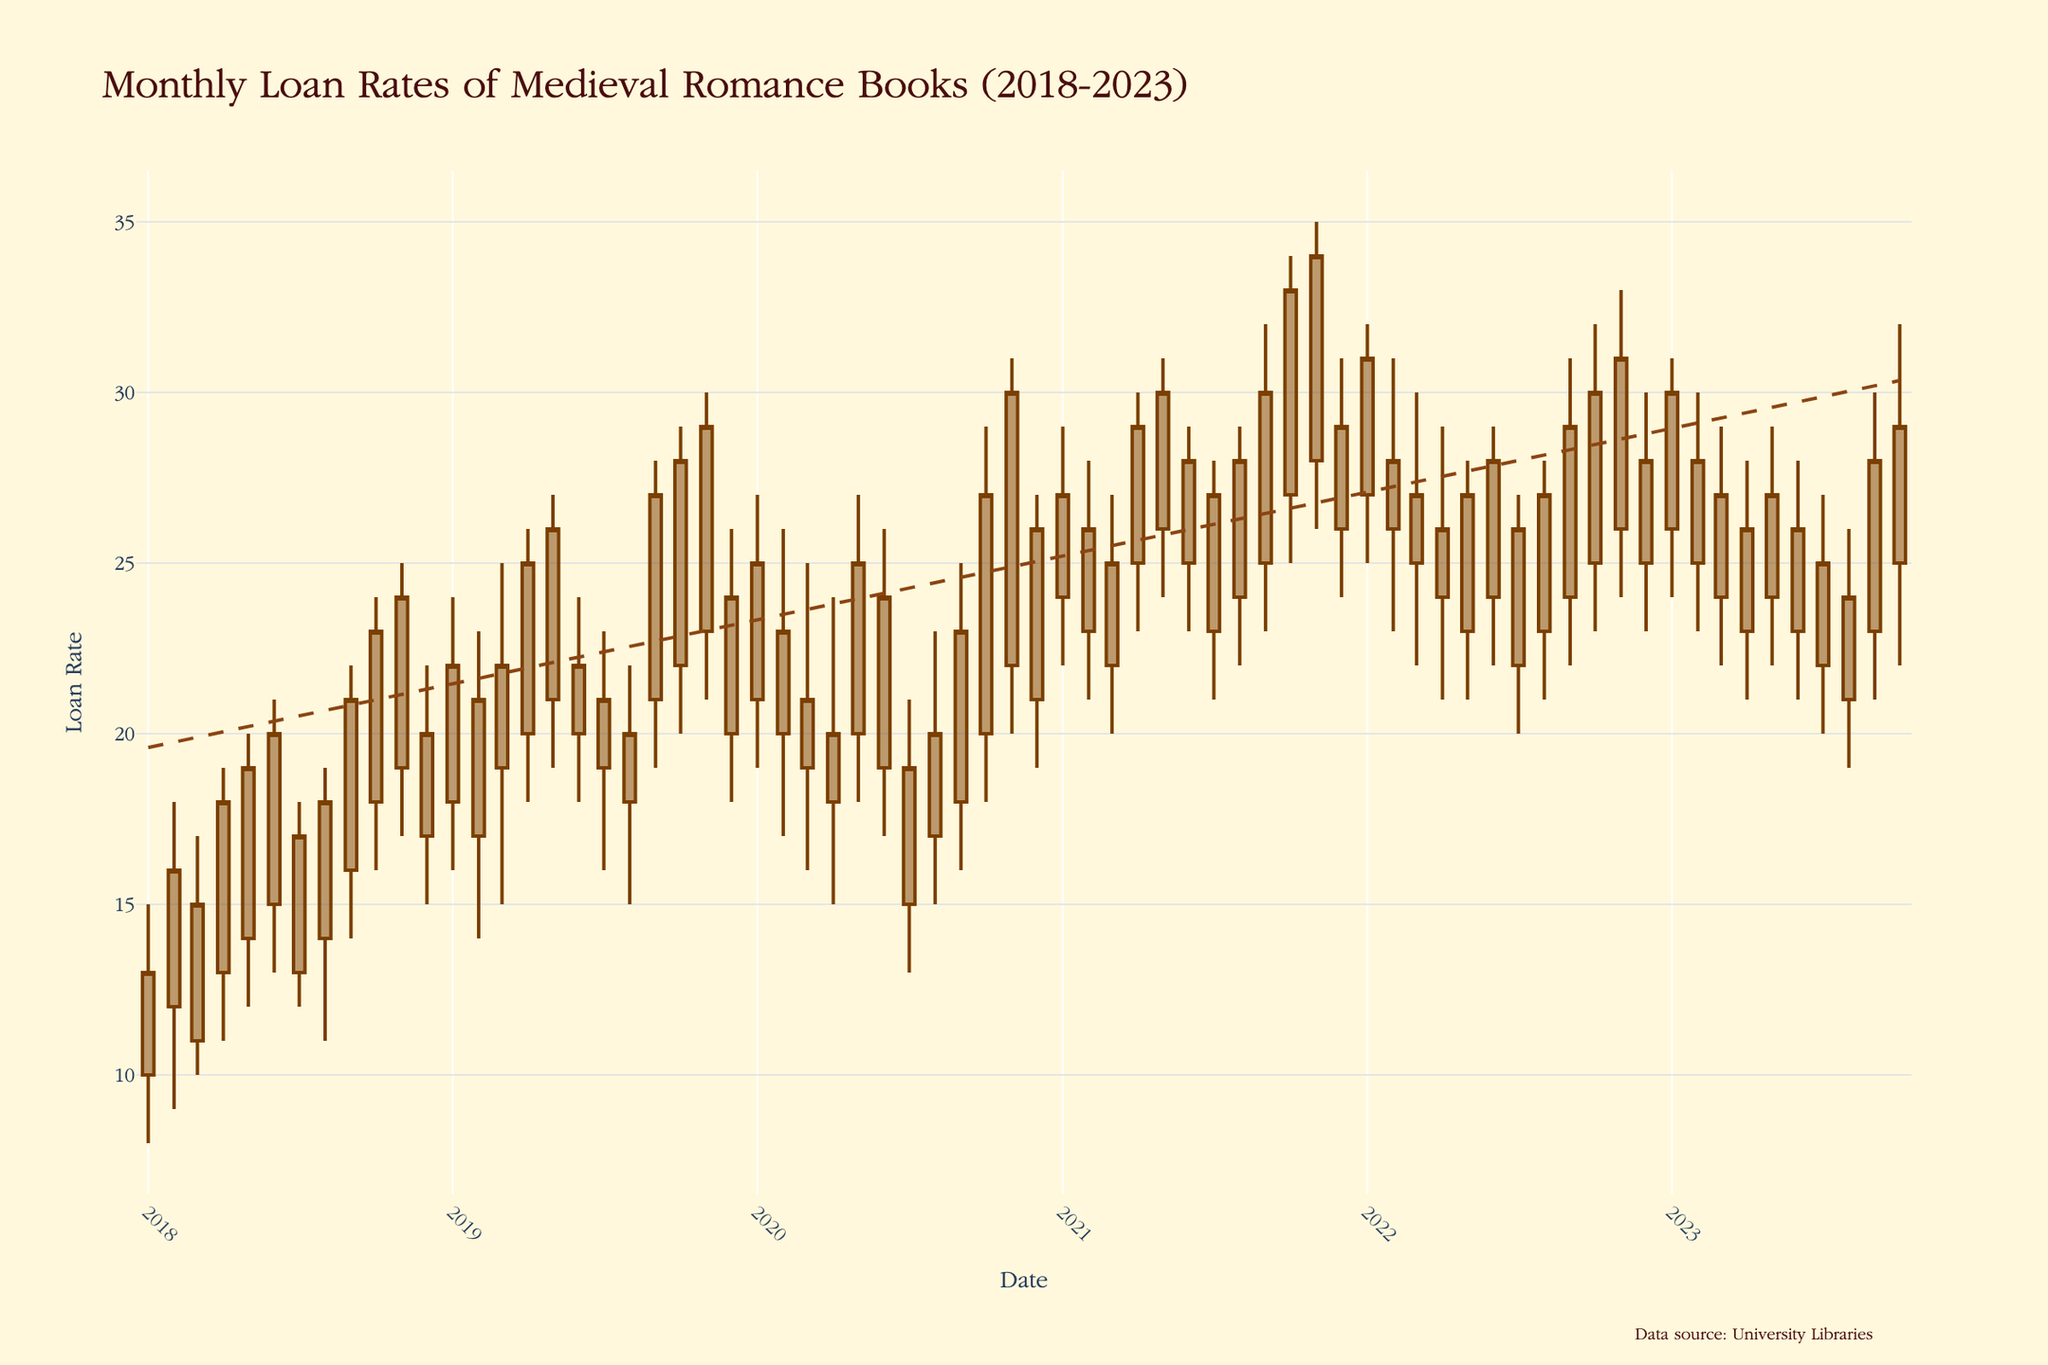What's the title of the plot? The title is displayed at the top of the figure.
Answer: Monthly Loan Rates of Medieval Romance Books (2018-2023) What is the historical range of years shown in the plot? The x-axis of the candlestick plot indicates the temporal range from the first to the last data point.
Answer: 2018-2023 In which month and year did the highest loan rate occur and what was its value? The highest value corresponds to the peak of the candlestick's "high" in November 2020.
Answer: November 2020, 31 What was the loan rate trend from the beginning to the end of 2020? Observing the plot, the candlesticks show the general movement of "close" values through 2020. The trend line can help provide a visual cue of this trend.
Answer: It generally increased, peaking in November Which year had the highest average closing loan rate? Calculate the average closing rate for each year and compare them. 2019 has the highest closing rates.
Answer: 2019 How did the loan rate change from September 2022 to October 2022? Compare the closing rates in these two months. September's close was 29 and October’s was 30.
Answer: It increased by 1 During which period(s) did the loan rates show a decreasing trend within a year? Identify sequences in the candlestick plot where the close values decrease over successive months. For  example, May to July 2023.
Answer: Multiple periods, e.g., May to July 2023 What was the lowest "low" value in the entire 5-year period and when did it occur? The plots lower points in candlestick or bars at the bottom represents the minimum values of 'low', which was 8 on January 2018.
Answer: January 2018, 8 How does the closing rate in December 2021 compare to that in December 2022? Refer to the closing rate at 'December 2021' and 'December 2022' to compare them. December 2021 closed at 29, and December 2022 at 28.
Answer: December 2021 is higher by 1 What is indicated by the dashed line in the plot? The dashed line represents a trend line on the visible data series, indicating an overall trend over the period.
Answer: Long-term trend of loan rates 